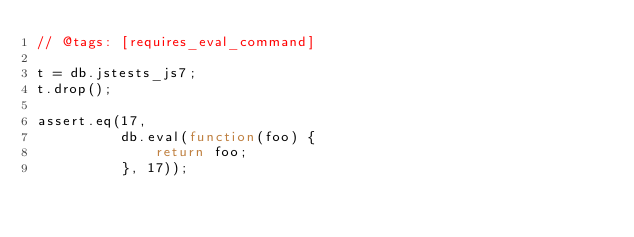<code> <loc_0><loc_0><loc_500><loc_500><_JavaScript_>// @tags: [requires_eval_command]

t = db.jstests_js7;
t.drop();

assert.eq(17,
          db.eval(function(foo) {
              return foo;
          }, 17));
</code> 